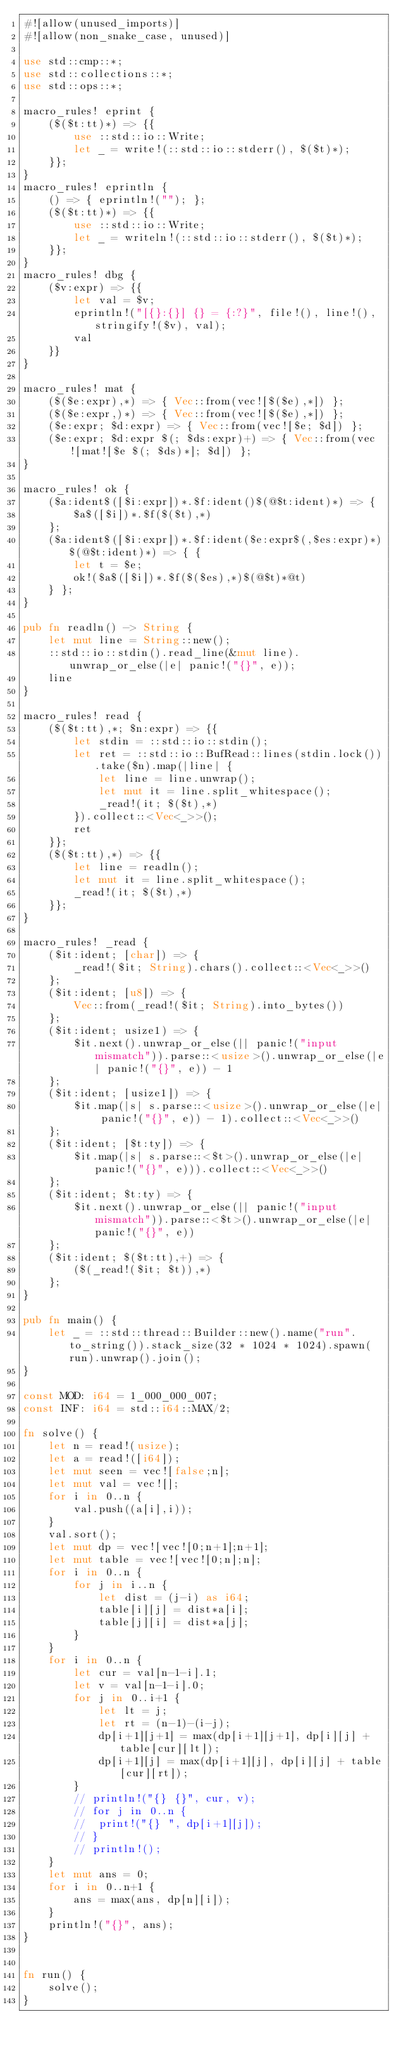Convert code to text. <code><loc_0><loc_0><loc_500><loc_500><_Rust_>#![allow(unused_imports)]
#![allow(non_snake_case, unused)]

use std::cmp::*;
use std::collections::*;
use std::ops::*;

macro_rules! eprint {
	($($t:tt)*) => {{
		use ::std::io::Write;
		let _ = write!(::std::io::stderr(), $($t)*);
	}};
}
macro_rules! eprintln {
	() => { eprintln!(""); };
	($($t:tt)*) => {{
		use ::std::io::Write;
		let _ = writeln!(::std::io::stderr(), $($t)*);
	}};
}
macro_rules! dbg {
	($v:expr) => {{
		let val = $v;
		eprintln!("[{}:{}] {} = {:?}", file!(), line!(), stringify!($v), val);
		val
	}}
}

macro_rules! mat {
	($($e:expr),*) => { Vec::from(vec![$($e),*]) };
	($($e:expr,)*) => { Vec::from(vec![$($e),*]) };
	($e:expr; $d:expr) => { Vec::from(vec![$e; $d]) };
	($e:expr; $d:expr $(; $ds:expr)+) => { Vec::from(vec![mat![$e $(; $ds)*]; $d]) };
}

macro_rules! ok {
	($a:ident$([$i:expr])*.$f:ident()$(@$t:ident)*) => {
		$a$([$i])*.$f($($t),*)
	};
	($a:ident$([$i:expr])*.$f:ident($e:expr$(,$es:expr)*)$(@$t:ident)*) => { {
		let t = $e;
		ok!($a$([$i])*.$f($($es),*)$(@$t)*@t)
	} };
}

pub fn readln() -> String {
	let mut line = String::new();
	::std::io::stdin().read_line(&mut line).unwrap_or_else(|e| panic!("{}", e));
	line
}

macro_rules! read {
	($($t:tt),*; $n:expr) => {{
		let stdin = ::std::io::stdin();
		let ret = ::std::io::BufRead::lines(stdin.lock()).take($n).map(|line| {
			let line = line.unwrap();
			let mut it = line.split_whitespace();
			_read!(it; $($t),*)
		}).collect::<Vec<_>>();
		ret
	}};
	($($t:tt),*) => {{
		let line = readln();
		let mut it = line.split_whitespace();
		_read!(it; $($t),*)
	}};
}

macro_rules! _read {
	($it:ident; [char]) => {
		_read!($it; String).chars().collect::<Vec<_>>()
	};
	($it:ident; [u8]) => {
		Vec::from(_read!($it; String).into_bytes())
	};
	($it:ident; usize1) => {
		$it.next().unwrap_or_else(|| panic!("input mismatch")).parse::<usize>().unwrap_or_else(|e| panic!("{}", e)) - 1
	};
	($it:ident; [usize1]) => {
		$it.map(|s| s.parse::<usize>().unwrap_or_else(|e| panic!("{}", e)) - 1).collect::<Vec<_>>()
	};
	($it:ident; [$t:ty]) => {
		$it.map(|s| s.parse::<$t>().unwrap_or_else(|e| panic!("{}", e))).collect::<Vec<_>>()
	};
	($it:ident; $t:ty) => {
		$it.next().unwrap_or_else(|| panic!("input mismatch")).parse::<$t>().unwrap_or_else(|e| panic!("{}", e))
	};
	($it:ident; $($t:tt),+) => {
		($(_read!($it; $t)),*)
	};
}

pub fn main() {
	let _ = ::std::thread::Builder::new().name("run".to_string()).stack_size(32 * 1024 * 1024).spawn(run).unwrap().join();
}

const MOD: i64 = 1_000_000_007;
const INF: i64 = std::i64::MAX/2;

fn solve() {
	let n = read!(usize);
	let a = read!([i64]);
	let mut seen = vec![false;n];
	let mut val = vec![];
	for i in 0..n {
		val.push((a[i],i));
	}
	val.sort();
	let mut dp = vec![vec![0;n+1];n+1];
	let mut table = vec![vec![0;n];n];
	for i in 0..n {
		for j in i..n {
			let dist = (j-i) as i64;
			table[i][j] = dist*a[i];
			table[j][i] = dist*a[j];
		}
	}
	for i in 0..n {
		let cur = val[n-1-i].1;
		let v = val[n-1-i].0;
		for j in 0..i+1 {
			let lt = j;
			let rt = (n-1)-(i-j);
			dp[i+1][j+1] = max(dp[i+1][j+1], dp[i][j] + table[cur][lt]);
			dp[i+1][j] = max(dp[i+1][j], dp[i][j] + table[cur][rt]);
		}
		// println!("{} {}", cur, v);
		// for j in 0..n {
		// 	print!("{} ", dp[i+1][j]);
		// }
		// println!();
	}
	let mut ans = 0;
	for i in 0..n+1 {
		ans = max(ans, dp[n][i]);
	}
	println!("{}", ans);
}


fn run() {
    solve();
}
</code> 